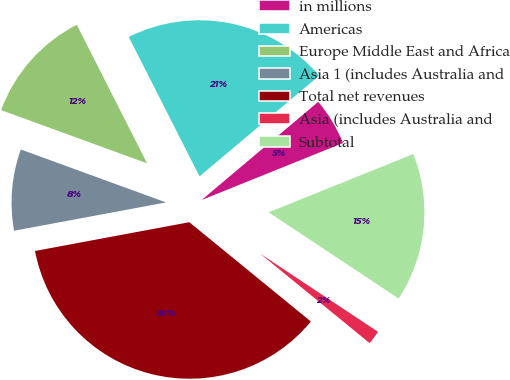Convert chart. <chart><loc_0><loc_0><loc_500><loc_500><pie_chart><fcel>in millions<fcel>Americas<fcel>Europe Middle East and Africa<fcel>Asia 1 (includes Australia and<fcel>Total net revenues<fcel>Asia (includes Australia and<fcel>Subtotal<nl><fcel>5.04%<fcel>21.34%<fcel>11.96%<fcel>8.5%<fcel>36.17%<fcel>1.58%<fcel>15.42%<nl></chart> 